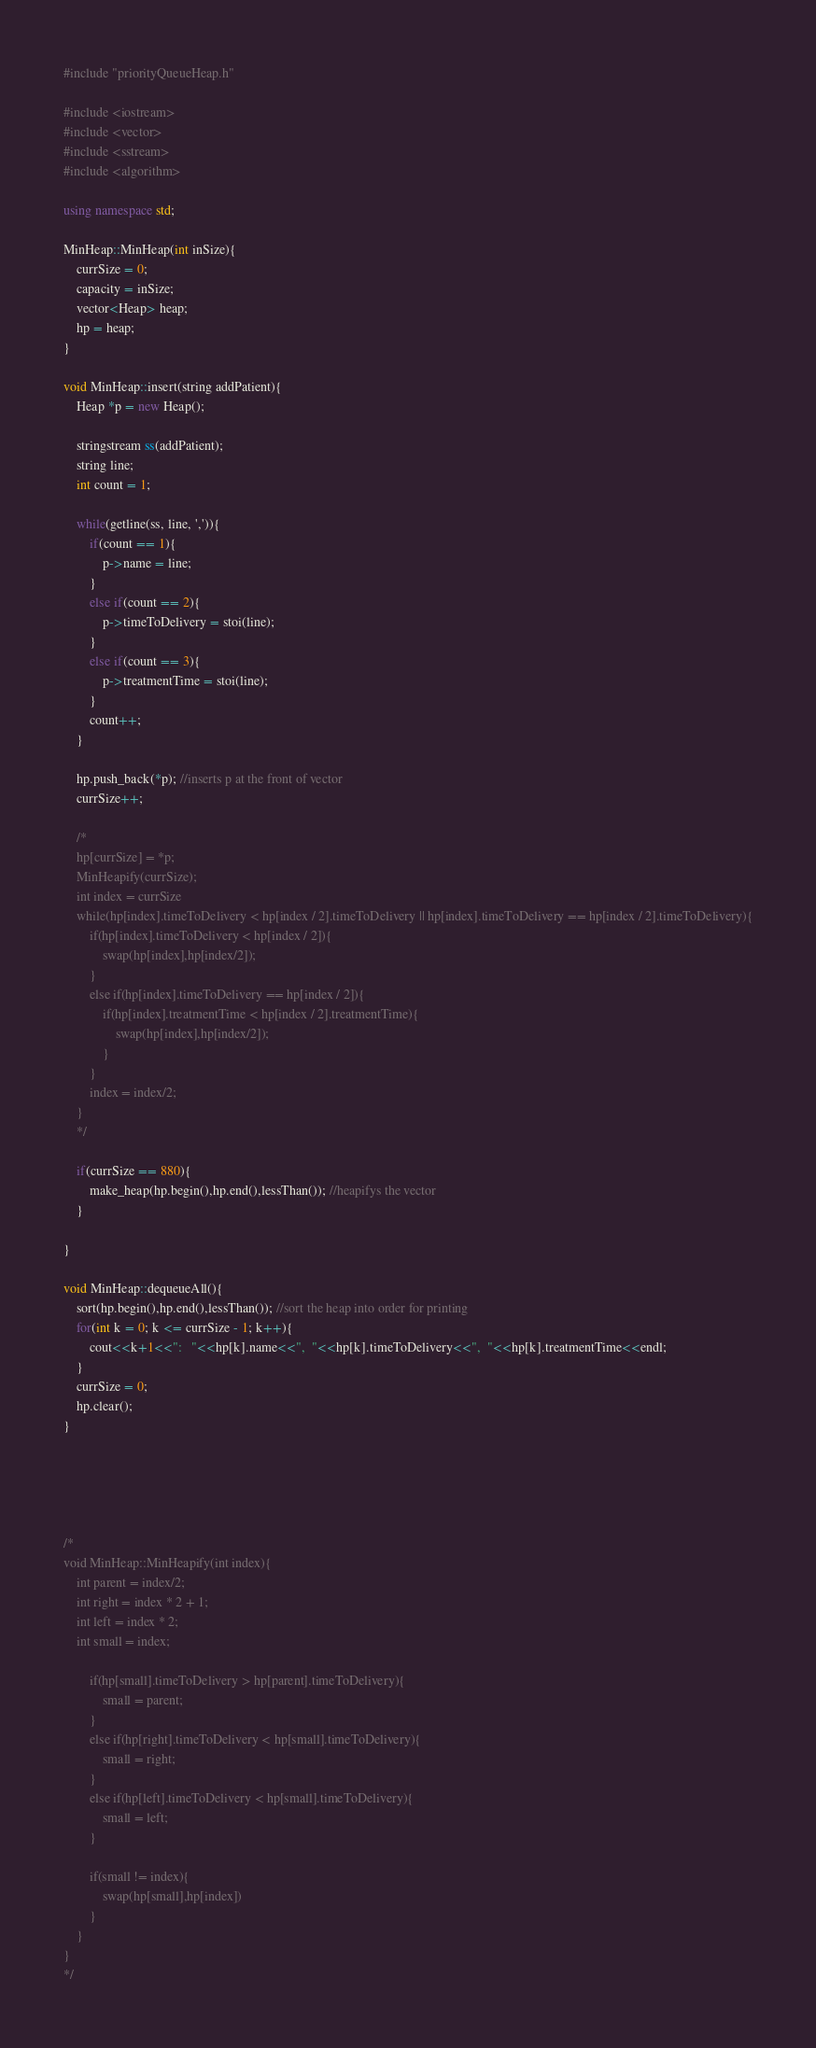<code> <loc_0><loc_0><loc_500><loc_500><_C++_>#include "priorityQueueHeap.h"

#include <iostream>
#include <vector>
#include <sstream>
#include <algorithm>

using namespace std;

MinHeap::MinHeap(int inSize){
	currSize = 0;
	capacity = inSize;
	vector<Heap> heap;
	hp = heap;
}

void MinHeap::insert(string addPatient){
	Heap *p = new Heap();

	stringstream ss(addPatient);
	string line;
	int count = 1;

	while(getline(ss, line, ',')){
		if(count == 1){
			p->name = line;
		}
		else if(count == 2){
			p->timeToDelivery = stoi(line);
		}
		else if(count == 3){
			p->treatmentTime = stoi(line);
		}
		count++;
	}

	hp.push_back(*p); //inserts p at the front of vector
	currSize++;

	/*
	hp[currSize] = *p;
	MinHeapify(currSize);
	int index = currSize
	while(hp[index].timeToDelivery < hp[index / 2].timeToDelivery || hp[index].timeToDelivery == hp[index / 2].timeToDelivery){
		if(hp[index].timeToDelivery < hp[index / 2]){
			swap(hp[index],hp[index/2]);
		}
		else if(hp[index].timeToDelivery == hp[index / 2]){
			if(hp[index].treatmentTime < hp[index / 2].treatmentTime){
				swap(hp[index],hp[index/2]);
			}
		}
		index = index/2;
	}
	*/

	if(currSize == 880){
	 	make_heap(hp.begin(),hp.end(),lessThan()); //heapifys the vector
	}

}

void MinHeap::dequeueAll(){
	sort(hp.begin(),hp.end(),lessThan()); //sort the heap into order for printing
	for(int k = 0; k <= currSize - 1; k++){
		cout<<k+1<<":	"<<hp[k].name<<",  "<<hp[k].timeToDelivery<<",  "<<hp[k].treatmentTime<<endl;
	}
	currSize = 0;
	hp.clear();
}





/*
void MinHeap::MinHeapify(int index){
	int parent = index/2;
	int right = index * 2 + 1;
	int left = index * 2;
	int small = index;

		if(hp[small].timeToDelivery > hp[parent].timeToDelivery){
			small = parent;
		}
		else if(hp[right].timeToDelivery < hp[small].timeToDelivery){
			small = right;
		}
		else if(hp[left].timeToDelivery < hp[small].timeToDelivery){
			small = left;
		}
		
		if(small != index){
			swap(hp[small],hp[index])
		}
	}
}
*/</code> 